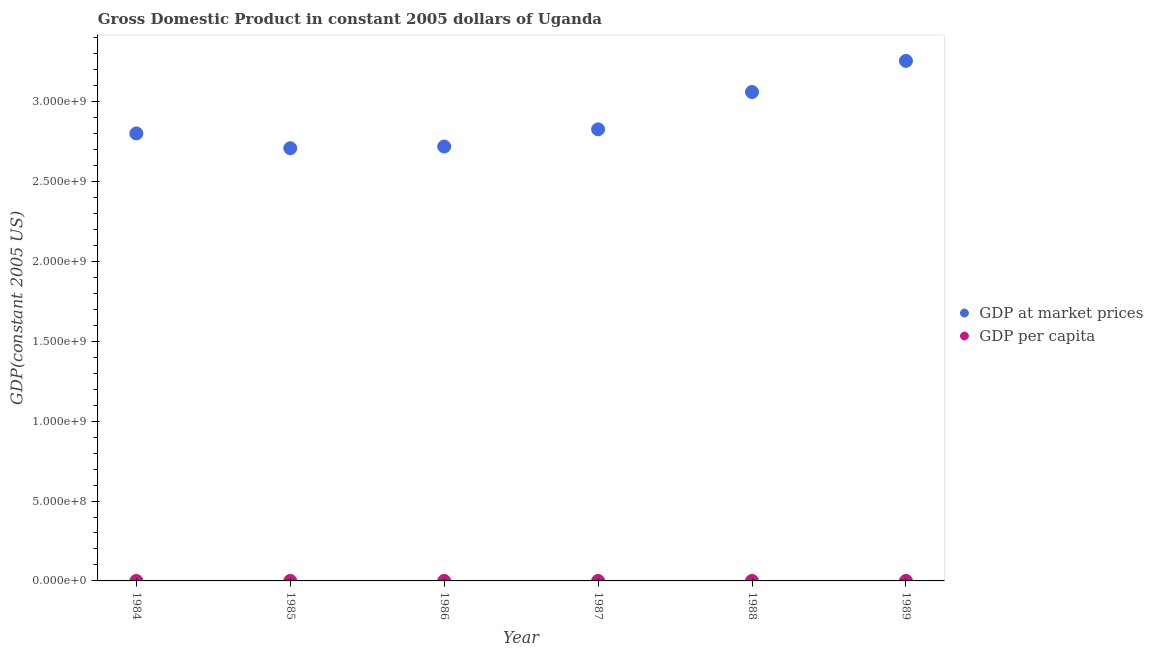Is the number of dotlines equal to the number of legend labels?
Your response must be concise. Yes. What is the gdp at market prices in 1989?
Your answer should be very brief. 3.25e+09. Across all years, what is the maximum gdp at market prices?
Offer a terse response. 3.25e+09. Across all years, what is the minimum gdp per capita?
Keep it short and to the point. 179.65. In which year was the gdp per capita maximum?
Offer a very short reply. 1984. What is the total gdp at market prices in the graph?
Ensure brevity in your answer.  1.74e+1. What is the difference between the gdp at market prices in 1984 and that in 1985?
Provide a short and direct response. 9.26e+07. What is the difference between the gdp at market prices in 1986 and the gdp per capita in 1984?
Make the answer very short. 2.72e+09. What is the average gdp at market prices per year?
Provide a succinct answer. 2.89e+09. In the year 1986, what is the difference between the gdp per capita and gdp at market prices?
Your answer should be very brief. -2.72e+09. In how many years, is the gdp at market prices greater than 1100000000 US$?
Your answer should be compact. 6. What is the ratio of the gdp at market prices in 1984 to that in 1989?
Provide a short and direct response. 0.86. What is the difference between the highest and the second highest gdp per capita?
Give a very brief answer. 4.04. What is the difference between the highest and the lowest gdp at market prices?
Your answer should be very brief. 5.47e+08. Does the gdp per capita monotonically increase over the years?
Provide a succinct answer. No. How many dotlines are there?
Offer a terse response. 2. What is the difference between two consecutive major ticks on the Y-axis?
Provide a short and direct response. 5.00e+08. Are the values on the major ticks of Y-axis written in scientific E-notation?
Ensure brevity in your answer.  Yes. Does the graph contain grids?
Your response must be concise. No. How many legend labels are there?
Give a very brief answer. 2. What is the title of the graph?
Ensure brevity in your answer.  Gross Domestic Product in constant 2005 dollars of Uganda. Does "Food" appear as one of the legend labels in the graph?
Give a very brief answer. No. What is the label or title of the Y-axis?
Your response must be concise. GDP(constant 2005 US). What is the GDP(constant 2005 US) in GDP at market prices in 1984?
Ensure brevity in your answer.  2.80e+09. What is the GDP(constant 2005 US) of GDP per capita in 1984?
Provide a short and direct response. 197.75. What is the GDP(constant 2005 US) of GDP at market prices in 1985?
Offer a terse response. 2.71e+09. What is the GDP(constant 2005 US) of GDP per capita in 1985?
Ensure brevity in your answer.  185.1. What is the GDP(constant 2005 US) of GDP at market prices in 1986?
Your answer should be compact. 2.72e+09. What is the GDP(constant 2005 US) in GDP per capita in 1986?
Your answer should be compact. 179.65. What is the GDP(constant 2005 US) of GDP at market prices in 1987?
Make the answer very short. 2.83e+09. What is the GDP(constant 2005 US) in GDP per capita in 1987?
Provide a short and direct response. 180.4. What is the GDP(constant 2005 US) in GDP at market prices in 1988?
Ensure brevity in your answer.  3.06e+09. What is the GDP(constant 2005 US) of GDP per capita in 1988?
Give a very brief answer. 188.58. What is the GDP(constant 2005 US) of GDP at market prices in 1989?
Offer a very short reply. 3.25e+09. What is the GDP(constant 2005 US) of GDP per capita in 1989?
Your answer should be compact. 193.72. Across all years, what is the maximum GDP(constant 2005 US) of GDP at market prices?
Provide a short and direct response. 3.25e+09. Across all years, what is the maximum GDP(constant 2005 US) of GDP per capita?
Ensure brevity in your answer.  197.75. Across all years, what is the minimum GDP(constant 2005 US) of GDP at market prices?
Make the answer very short. 2.71e+09. Across all years, what is the minimum GDP(constant 2005 US) in GDP per capita?
Your answer should be compact. 179.65. What is the total GDP(constant 2005 US) of GDP at market prices in the graph?
Provide a succinct answer. 1.74e+1. What is the total GDP(constant 2005 US) of GDP per capita in the graph?
Keep it short and to the point. 1125.19. What is the difference between the GDP(constant 2005 US) of GDP at market prices in 1984 and that in 1985?
Provide a short and direct response. 9.26e+07. What is the difference between the GDP(constant 2005 US) of GDP per capita in 1984 and that in 1985?
Ensure brevity in your answer.  12.65. What is the difference between the GDP(constant 2005 US) of GDP at market prices in 1984 and that in 1986?
Your answer should be very brief. 8.20e+07. What is the difference between the GDP(constant 2005 US) of GDP per capita in 1984 and that in 1986?
Your answer should be very brief. 18.1. What is the difference between the GDP(constant 2005 US) in GDP at market prices in 1984 and that in 1987?
Your answer should be compact. -2.57e+07. What is the difference between the GDP(constant 2005 US) in GDP per capita in 1984 and that in 1987?
Provide a succinct answer. 17.36. What is the difference between the GDP(constant 2005 US) of GDP at market prices in 1984 and that in 1988?
Provide a succinct answer. -2.59e+08. What is the difference between the GDP(constant 2005 US) of GDP per capita in 1984 and that in 1988?
Your answer should be compact. 9.18. What is the difference between the GDP(constant 2005 US) of GDP at market prices in 1984 and that in 1989?
Keep it short and to the point. -4.54e+08. What is the difference between the GDP(constant 2005 US) in GDP per capita in 1984 and that in 1989?
Offer a terse response. 4.04. What is the difference between the GDP(constant 2005 US) of GDP at market prices in 1985 and that in 1986?
Provide a succinct answer. -1.06e+07. What is the difference between the GDP(constant 2005 US) of GDP per capita in 1985 and that in 1986?
Make the answer very short. 5.45. What is the difference between the GDP(constant 2005 US) of GDP at market prices in 1985 and that in 1987?
Provide a succinct answer. -1.18e+08. What is the difference between the GDP(constant 2005 US) of GDP per capita in 1985 and that in 1987?
Keep it short and to the point. 4.7. What is the difference between the GDP(constant 2005 US) in GDP at market prices in 1985 and that in 1988?
Make the answer very short. -3.52e+08. What is the difference between the GDP(constant 2005 US) of GDP per capita in 1985 and that in 1988?
Give a very brief answer. -3.48. What is the difference between the GDP(constant 2005 US) in GDP at market prices in 1985 and that in 1989?
Provide a succinct answer. -5.47e+08. What is the difference between the GDP(constant 2005 US) in GDP per capita in 1985 and that in 1989?
Your answer should be compact. -8.62. What is the difference between the GDP(constant 2005 US) in GDP at market prices in 1986 and that in 1987?
Ensure brevity in your answer.  -1.08e+08. What is the difference between the GDP(constant 2005 US) of GDP per capita in 1986 and that in 1987?
Provide a succinct answer. -0.75. What is the difference between the GDP(constant 2005 US) of GDP at market prices in 1986 and that in 1988?
Provide a succinct answer. -3.41e+08. What is the difference between the GDP(constant 2005 US) in GDP per capita in 1986 and that in 1988?
Make the answer very short. -8.93. What is the difference between the GDP(constant 2005 US) in GDP at market prices in 1986 and that in 1989?
Provide a succinct answer. -5.36e+08. What is the difference between the GDP(constant 2005 US) in GDP per capita in 1986 and that in 1989?
Provide a succinct answer. -14.06. What is the difference between the GDP(constant 2005 US) in GDP at market prices in 1987 and that in 1988?
Your answer should be compact. -2.34e+08. What is the difference between the GDP(constant 2005 US) in GDP per capita in 1987 and that in 1988?
Provide a short and direct response. -8.18. What is the difference between the GDP(constant 2005 US) in GDP at market prices in 1987 and that in 1989?
Offer a very short reply. -4.28e+08. What is the difference between the GDP(constant 2005 US) in GDP per capita in 1987 and that in 1989?
Provide a succinct answer. -13.32. What is the difference between the GDP(constant 2005 US) in GDP at market prices in 1988 and that in 1989?
Offer a very short reply. -1.95e+08. What is the difference between the GDP(constant 2005 US) of GDP per capita in 1988 and that in 1989?
Your answer should be very brief. -5.14. What is the difference between the GDP(constant 2005 US) in GDP at market prices in 1984 and the GDP(constant 2005 US) in GDP per capita in 1985?
Offer a terse response. 2.80e+09. What is the difference between the GDP(constant 2005 US) of GDP at market prices in 1984 and the GDP(constant 2005 US) of GDP per capita in 1986?
Your answer should be very brief. 2.80e+09. What is the difference between the GDP(constant 2005 US) of GDP at market prices in 1984 and the GDP(constant 2005 US) of GDP per capita in 1987?
Your answer should be compact. 2.80e+09. What is the difference between the GDP(constant 2005 US) of GDP at market prices in 1984 and the GDP(constant 2005 US) of GDP per capita in 1988?
Your answer should be compact. 2.80e+09. What is the difference between the GDP(constant 2005 US) of GDP at market prices in 1984 and the GDP(constant 2005 US) of GDP per capita in 1989?
Your answer should be very brief. 2.80e+09. What is the difference between the GDP(constant 2005 US) in GDP at market prices in 1985 and the GDP(constant 2005 US) in GDP per capita in 1986?
Keep it short and to the point. 2.71e+09. What is the difference between the GDP(constant 2005 US) in GDP at market prices in 1985 and the GDP(constant 2005 US) in GDP per capita in 1987?
Give a very brief answer. 2.71e+09. What is the difference between the GDP(constant 2005 US) of GDP at market prices in 1985 and the GDP(constant 2005 US) of GDP per capita in 1988?
Make the answer very short. 2.71e+09. What is the difference between the GDP(constant 2005 US) in GDP at market prices in 1985 and the GDP(constant 2005 US) in GDP per capita in 1989?
Provide a short and direct response. 2.71e+09. What is the difference between the GDP(constant 2005 US) in GDP at market prices in 1986 and the GDP(constant 2005 US) in GDP per capita in 1987?
Offer a very short reply. 2.72e+09. What is the difference between the GDP(constant 2005 US) in GDP at market prices in 1986 and the GDP(constant 2005 US) in GDP per capita in 1988?
Keep it short and to the point. 2.72e+09. What is the difference between the GDP(constant 2005 US) in GDP at market prices in 1986 and the GDP(constant 2005 US) in GDP per capita in 1989?
Provide a short and direct response. 2.72e+09. What is the difference between the GDP(constant 2005 US) of GDP at market prices in 1987 and the GDP(constant 2005 US) of GDP per capita in 1988?
Offer a very short reply. 2.83e+09. What is the difference between the GDP(constant 2005 US) in GDP at market prices in 1987 and the GDP(constant 2005 US) in GDP per capita in 1989?
Provide a succinct answer. 2.83e+09. What is the difference between the GDP(constant 2005 US) in GDP at market prices in 1988 and the GDP(constant 2005 US) in GDP per capita in 1989?
Provide a short and direct response. 3.06e+09. What is the average GDP(constant 2005 US) of GDP at market prices per year?
Provide a succinct answer. 2.89e+09. What is the average GDP(constant 2005 US) in GDP per capita per year?
Keep it short and to the point. 187.53. In the year 1984, what is the difference between the GDP(constant 2005 US) of GDP at market prices and GDP(constant 2005 US) of GDP per capita?
Your answer should be compact. 2.80e+09. In the year 1985, what is the difference between the GDP(constant 2005 US) of GDP at market prices and GDP(constant 2005 US) of GDP per capita?
Your answer should be compact. 2.71e+09. In the year 1986, what is the difference between the GDP(constant 2005 US) in GDP at market prices and GDP(constant 2005 US) in GDP per capita?
Your answer should be compact. 2.72e+09. In the year 1987, what is the difference between the GDP(constant 2005 US) of GDP at market prices and GDP(constant 2005 US) of GDP per capita?
Provide a succinct answer. 2.83e+09. In the year 1988, what is the difference between the GDP(constant 2005 US) of GDP at market prices and GDP(constant 2005 US) of GDP per capita?
Your answer should be very brief. 3.06e+09. In the year 1989, what is the difference between the GDP(constant 2005 US) in GDP at market prices and GDP(constant 2005 US) in GDP per capita?
Give a very brief answer. 3.25e+09. What is the ratio of the GDP(constant 2005 US) in GDP at market prices in 1984 to that in 1985?
Offer a very short reply. 1.03. What is the ratio of the GDP(constant 2005 US) of GDP per capita in 1984 to that in 1985?
Your response must be concise. 1.07. What is the ratio of the GDP(constant 2005 US) in GDP at market prices in 1984 to that in 1986?
Offer a terse response. 1.03. What is the ratio of the GDP(constant 2005 US) of GDP per capita in 1984 to that in 1986?
Your response must be concise. 1.1. What is the ratio of the GDP(constant 2005 US) of GDP at market prices in 1984 to that in 1987?
Keep it short and to the point. 0.99. What is the ratio of the GDP(constant 2005 US) of GDP per capita in 1984 to that in 1987?
Your answer should be very brief. 1.1. What is the ratio of the GDP(constant 2005 US) in GDP at market prices in 1984 to that in 1988?
Give a very brief answer. 0.92. What is the ratio of the GDP(constant 2005 US) of GDP per capita in 1984 to that in 1988?
Offer a very short reply. 1.05. What is the ratio of the GDP(constant 2005 US) in GDP at market prices in 1984 to that in 1989?
Offer a terse response. 0.86. What is the ratio of the GDP(constant 2005 US) of GDP per capita in 1984 to that in 1989?
Offer a terse response. 1.02. What is the ratio of the GDP(constant 2005 US) of GDP per capita in 1985 to that in 1986?
Offer a terse response. 1.03. What is the ratio of the GDP(constant 2005 US) in GDP at market prices in 1985 to that in 1987?
Your answer should be compact. 0.96. What is the ratio of the GDP(constant 2005 US) of GDP per capita in 1985 to that in 1987?
Keep it short and to the point. 1.03. What is the ratio of the GDP(constant 2005 US) in GDP at market prices in 1985 to that in 1988?
Your response must be concise. 0.89. What is the ratio of the GDP(constant 2005 US) of GDP per capita in 1985 to that in 1988?
Provide a succinct answer. 0.98. What is the ratio of the GDP(constant 2005 US) in GDP at market prices in 1985 to that in 1989?
Provide a short and direct response. 0.83. What is the ratio of the GDP(constant 2005 US) of GDP per capita in 1985 to that in 1989?
Your response must be concise. 0.96. What is the ratio of the GDP(constant 2005 US) of GDP at market prices in 1986 to that in 1987?
Keep it short and to the point. 0.96. What is the ratio of the GDP(constant 2005 US) in GDP at market prices in 1986 to that in 1988?
Provide a short and direct response. 0.89. What is the ratio of the GDP(constant 2005 US) in GDP per capita in 1986 to that in 1988?
Your answer should be very brief. 0.95. What is the ratio of the GDP(constant 2005 US) in GDP at market prices in 1986 to that in 1989?
Make the answer very short. 0.84. What is the ratio of the GDP(constant 2005 US) in GDP per capita in 1986 to that in 1989?
Ensure brevity in your answer.  0.93. What is the ratio of the GDP(constant 2005 US) in GDP at market prices in 1987 to that in 1988?
Ensure brevity in your answer.  0.92. What is the ratio of the GDP(constant 2005 US) of GDP per capita in 1987 to that in 1988?
Ensure brevity in your answer.  0.96. What is the ratio of the GDP(constant 2005 US) of GDP at market prices in 1987 to that in 1989?
Give a very brief answer. 0.87. What is the ratio of the GDP(constant 2005 US) of GDP per capita in 1987 to that in 1989?
Your answer should be very brief. 0.93. What is the ratio of the GDP(constant 2005 US) of GDP at market prices in 1988 to that in 1989?
Offer a very short reply. 0.94. What is the ratio of the GDP(constant 2005 US) of GDP per capita in 1988 to that in 1989?
Offer a very short reply. 0.97. What is the difference between the highest and the second highest GDP(constant 2005 US) in GDP at market prices?
Offer a terse response. 1.95e+08. What is the difference between the highest and the second highest GDP(constant 2005 US) of GDP per capita?
Offer a very short reply. 4.04. What is the difference between the highest and the lowest GDP(constant 2005 US) in GDP at market prices?
Your answer should be compact. 5.47e+08. What is the difference between the highest and the lowest GDP(constant 2005 US) of GDP per capita?
Your answer should be compact. 18.1. 